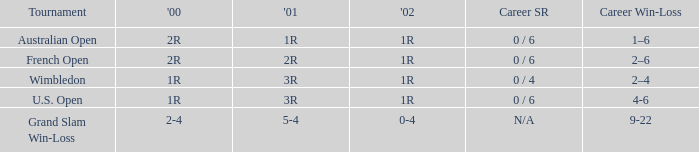Which career win-loss record has a 1r in 2002, a 2r in 2000 and a 2r in 2001? 2–6. Could you help me parse every detail presented in this table? {'header': ['Tournament', "'00", "'01", "'02", 'Career SR', 'Career Win-Loss'], 'rows': [['Australian Open', '2R', '1R', '1R', '0 / 6', '1–6'], ['French Open', '2R', '2R', '1R', '0 / 6', '2–6'], ['Wimbledon', '1R', '3R', '1R', '0 / 4', '2–4'], ['U.S. Open', '1R', '3R', '1R', '0 / 6', '4-6'], ['Grand Slam Win-Loss', '2-4', '5-4', '0-4', 'N/A', '9-22']]} 